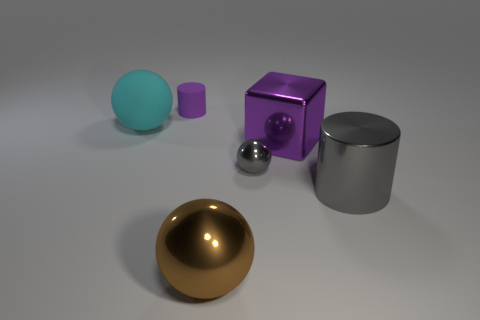How many large cubes are the same color as the small rubber object?
Your answer should be very brief. 1. What shape is the big shiny object that is the same color as the tiny matte cylinder?
Provide a succinct answer. Cube. What number of other things are made of the same material as the gray sphere?
Your answer should be compact. 3. Is there a small purple object that is in front of the gray metallic object that is behind the gray cylinder?
Offer a terse response. No. Are there any other things that are the same shape as the tiny gray metallic thing?
Offer a terse response. Yes. The large metallic thing that is the same shape as the big matte thing is what color?
Offer a very short reply. Brown. What size is the metallic cylinder?
Offer a very short reply. Large. Are there fewer gray metal balls that are behind the purple shiny object than big purple metallic objects?
Provide a succinct answer. Yes. Are the big cyan sphere and the cylinder that is behind the large gray cylinder made of the same material?
Offer a very short reply. Yes. Are there any big cylinders that are behind the rubber object to the left of the purple thing that is left of the large brown metallic object?
Your answer should be very brief. No. 